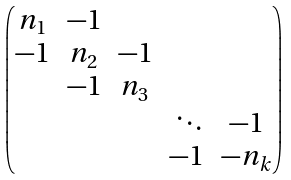<formula> <loc_0><loc_0><loc_500><loc_500>\begin{pmatrix} n _ { 1 } & - 1 & & & \\ - 1 & n _ { 2 } & - 1 & & \\ & - 1 & n _ { 3 } & & \\ & & & \ \ddots & - 1 \\ & & & - 1 & - n _ { k } \\ \end{pmatrix}</formula> 